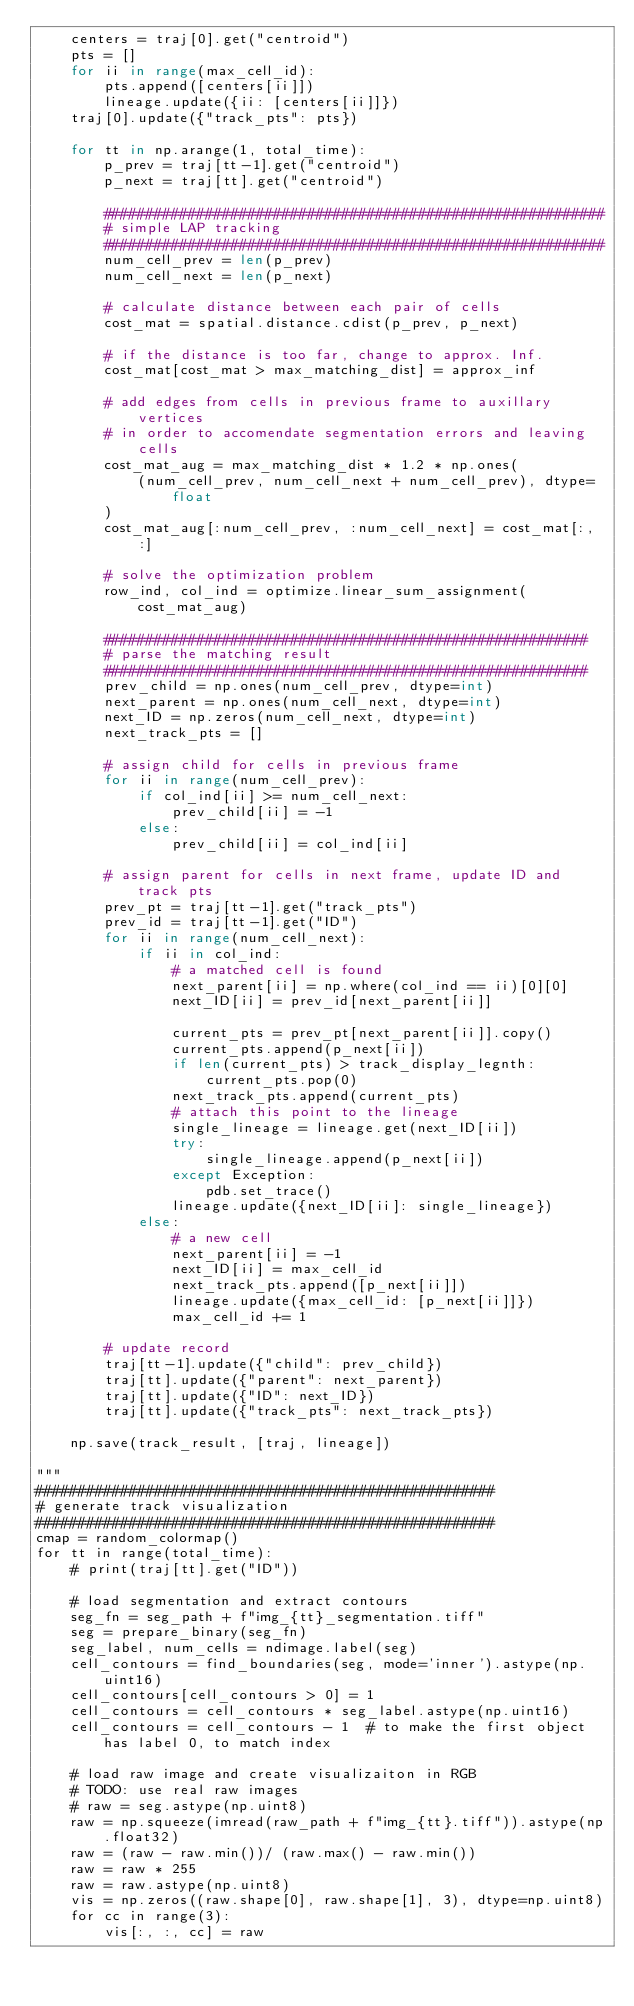Convert code to text. <code><loc_0><loc_0><loc_500><loc_500><_Python_>    centers = traj[0].get("centroid")
    pts = []
    for ii in range(max_cell_id):
        pts.append([centers[ii]])
        lineage.update({ii: [centers[ii]]})
    traj[0].update({"track_pts": pts})

    for tt in np.arange(1, total_time):
        p_prev = traj[tt-1].get("centroid")
        p_next = traj[tt].get("centroid")

        ###########################################################
        # simple LAP tracking
        ###########################################################
        num_cell_prev = len(p_prev)
        num_cell_next = len(p_next)

        # calculate distance between each pair of cells
        cost_mat = spatial.distance.cdist(p_prev, p_next)

        # if the distance is too far, change to approx. Inf.
        cost_mat[cost_mat > max_matching_dist] = approx_inf

        # add edges from cells in previous frame to auxillary vertices
        # in order to accomendate segmentation errors and leaving cells
        cost_mat_aug = max_matching_dist * 1.2 * np.ones(
            (num_cell_prev, num_cell_next + num_cell_prev), dtype=float
        )
        cost_mat_aug[:num_cell_prev, :num_cell_next] = cost_mat[:, :]

        # solve the optimization problem
        row_ind, col_ind = optimize.linear_sum_assignment(cost_mat_aug)

        #########################################################
        # parse the matching result
        #########################################################
        prev_child = np.ones(num_cell_prev, dtype=int)
        next_parent = np.ones(num_cell_next, dtype=int)
        next_ID = np.zeros(num_cell_next, dtype=int)
        next_track_pts = []

        # assign child for cells in previous frame
        for ii in range(num_cell_prev):
            if col_ind[ii] >= num_cell_next:
                prev_child[ii] = -1
            else:
                prev_child[ii] = col_ind[ii]

        # assign parent for cells in next frame, update ID and track pts
        prev_pt = traj[tt-1].get("track_pts")
        prev_id = traj[tt-1].get("ID")
        for ii in range(num_cell_next):
            if ii in col_ind:
                # a matched cell is found
                next_parent[ii] = np.where(col_ind == ii)[0][0]
                next_ID[ii] = prev_id[next_parent[ii]]
                
                current_pts = prev_pt[next_parent[ii]].copy()
                current_pts.append(p_next[ii])
                if len(current_pts) > track_display_legnth:
                    current_pts.pop(0)
                next_track_pts.append(current_pts)
                # attach this point to the lineage
                single_lineage = lineage.get(next_ID[ii])
                try:
                    single_lineage.append(p_next[ii])
                except Exception:
                    pdb.set_trace()
                lineage.update({next_ID[ii]: single_lineage})
            else:
                # a new cell
                next_parent[ii] = -1
                next_ID[ii] = max_cell_id
                next_track_pts.append([p_next[ii]])
                lineage.update({max_cell_id: [p_next[ii]]})
                max_cell_id += 1

        # update record
        traj[tt-1].update({"child": prev_child})
        traj[tt].update({"parent": next_parent})
        traj[tt].update({"ID": next_ID})
        traj[tt].update({"track_pts": next_track_pts})

    np.save(track_result, [traj, lineage])

"""
######################################################
# generate track visualization
######################################################
cmap = random_colormap()
for tt in range(total_time):
    # print(traj[tt].get("ID"))

    # load segmentation and extract contours
    seg_fn = seg_path + f"img_{tt}_segmentation.tiff"
    seg = prepare_binary(seg_fn)
    seg_label, num_cells = ndimage.label(seg)
    cell_contours = find_boundaries(seg, mode='inner').astype(np.uint16)
    cell_contours[cell_contours > 0] = 1
    cell_contours = cell_contours * seg_label.astype(np.uint16)
    cell_contours = cell_contours - 1  # to make the first object has label 0, to match index

    # load raw image and create visualizaiton in RGB
    # TODO: use real raw images
    # raw = seg.astype(np.uint8)
    raw = np.squeeze(imread(raw_path + f"img_{tt}.tiff")).astype(np.float32)
    raw = (raw - raw.min())/ (raw.max() - raw.min())
    raw = raw * 255
    raw = raw.astype(np.uint8)
    vis = np.zeros((raw.shape[0], raw.shape[1], 3), dtype=np.uint8)
    for cc in range(3):
        vis[:, :, cc] = raw
</code> 